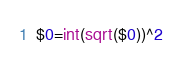<code> <loc_0><loc_0><loc_500><loc_500><_Awk_>$0=int(sqrt($0))^2</code> 